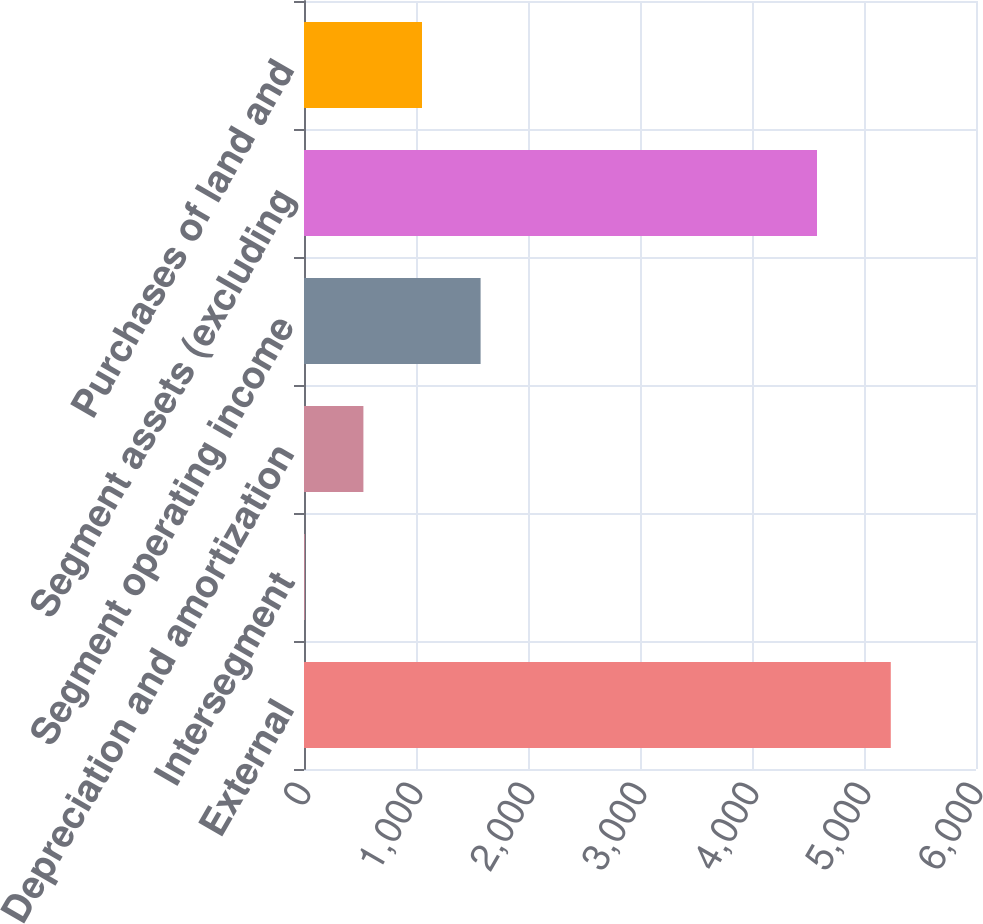<chart> <loc_0><loc_0><loc_500><loc_500><bar_chart><fcel>External<fcel>Intersegment<fcel>Depreciation and amortization<fcel>Segment operating income<fcel>Segment assets (excluding<fcel>Purchases of land and<nl><fcel>5239.1<fcel>7.2<fcel>530.39<fcel>1576.77<fcel>4580.4<fcel>1053.58<nl></chart> 